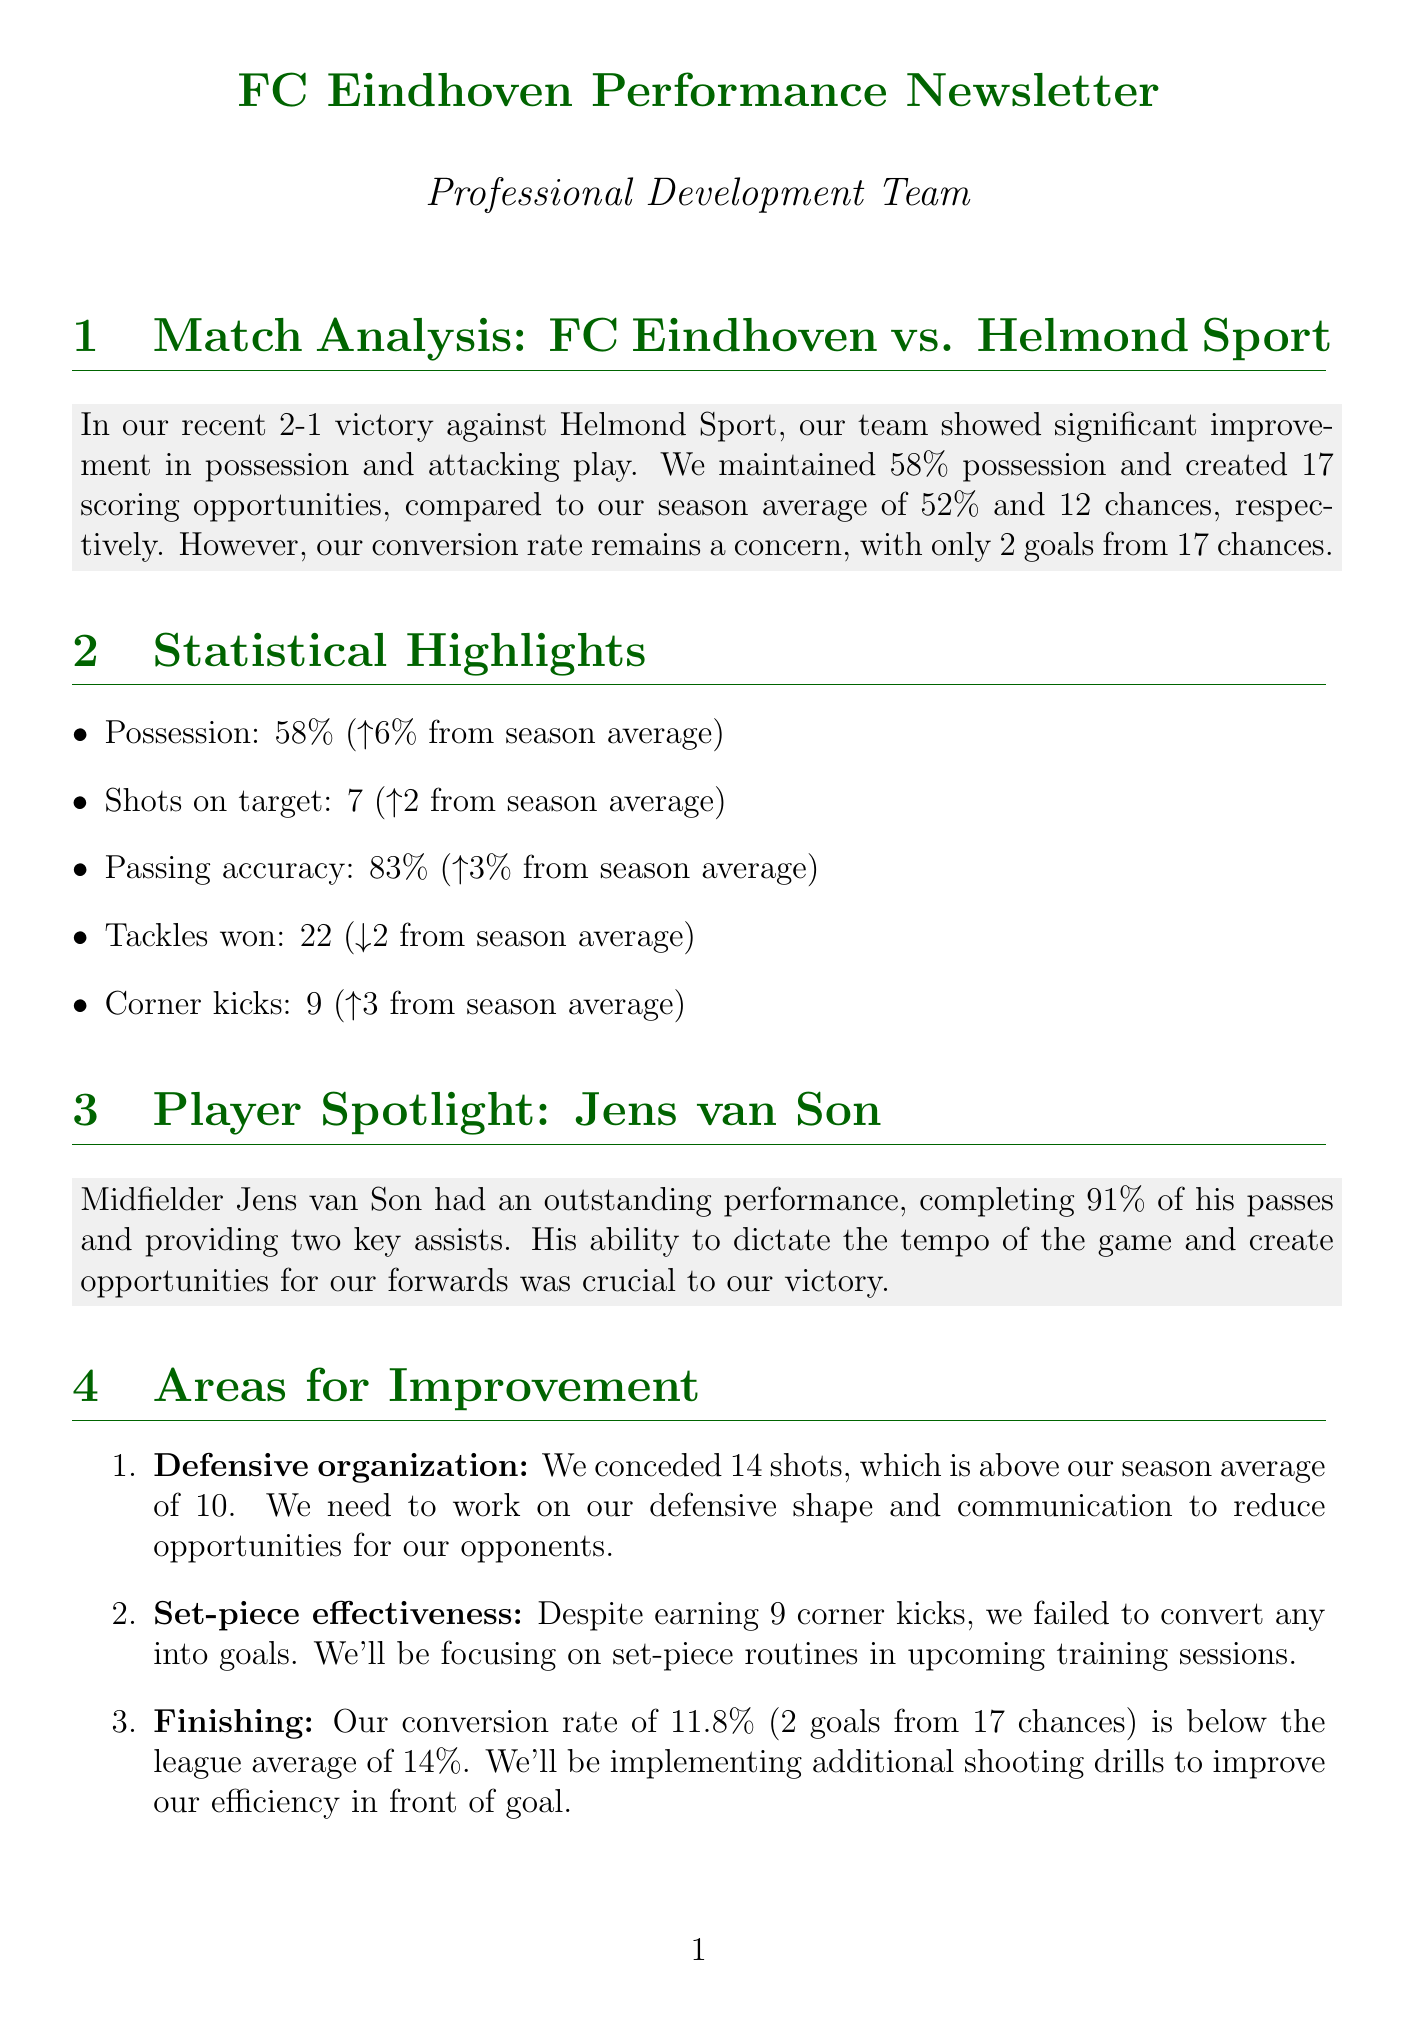What was the final score of the match? The content mentions a 2-1 victory against Helmond Sport.
Answer: 2-1 What percentage of possession did FC Eindhoven maintain? The match analysis states that the team maintained 58% possession.
Answer: 58% How many scoring opportunities did the team create? It is stated in the match analysis that they created 17 scoring opportunities.
Answer: 17 Who was highlighted as the player of the match? The newsletter specifically spotlights midfielder Jens van Son.
Answer: Jens van Son What was FC Eindhoven's conversion rate in the match? The newsletter mentions a conversion rate of 11.8% (2 goals from 17 chances).
Answer: 11.8% How many corner kicks did FC Eindhoven earn? The statistical highlights indicate that the team earned 9 corner kicks.
Answer: 9 What area needs improvement regarding defensive performance? The newsletter discusses the need for improvement in defensive organization.
Answer: Defensive organization Against which team will FC Eindhoven compete next? The upcoming fixture section states that their next match is against NAC Breda.
Answer: NAC Breda What is the focus of training on Wednesday? The training focus for the week lists set-piece routines and finishing exercises for Wednesday.
Answer: Set-piece routines and finishing exercises 